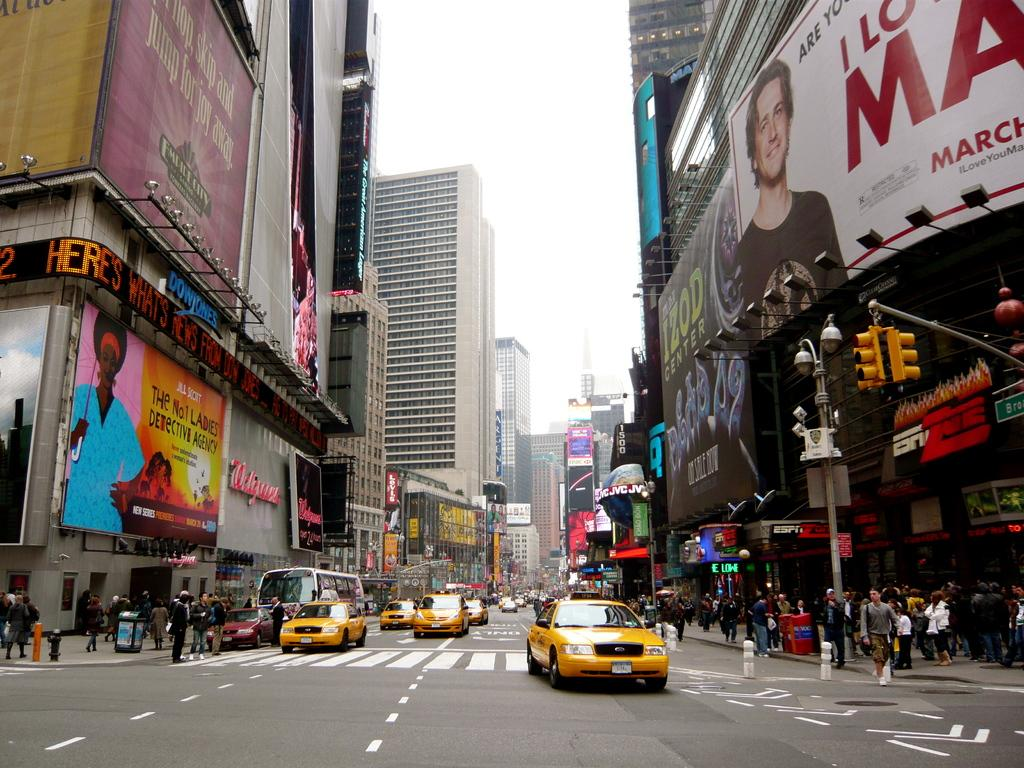<image>
Share a concise interpretation of the image provided. A busy city area has a sign that reads, "The No.1 Ladies Detective Agency". 